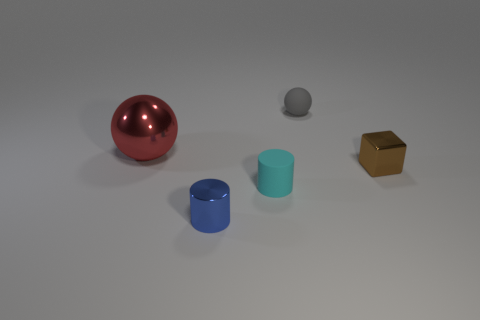Add 1 red objects. How many objects exist? 6 Subtract all cubes. How many objects are left? 4 Add 2 small metal cylinders. How many small metal cylinders are left? 3 Add 1 big red things. How many big red things exist? 2 Subtract 0 green cylinders. How many objects are left? 5 Subtract all small blue things. Subtract all cyan cylinders. How many objects are left? 3 